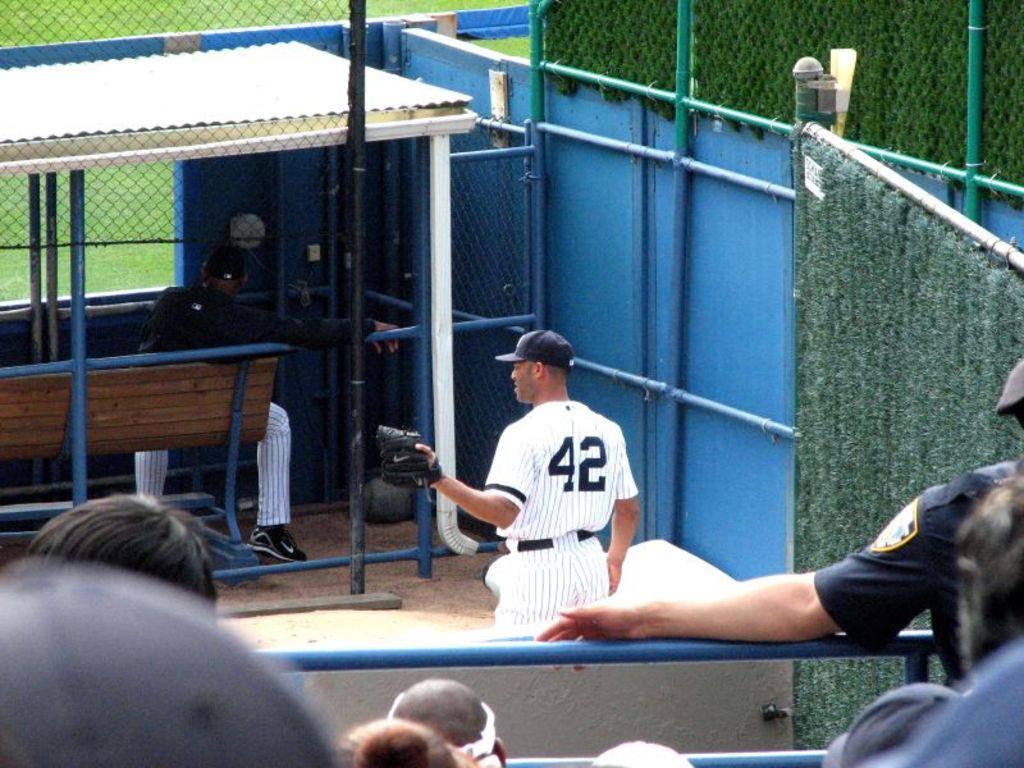What is the second number on back of the jersey?
Your answer should be very brief. 2. 